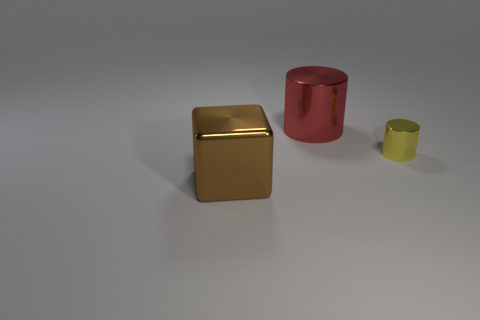Add 1 red metal cylinders. How many objects exist? 4 Subtract all cylinders. How many objects are left? 1 Add 2 cyan cylinders. How many cyan cylinders exist? 2 Subtract 0 purple cylinders. How many objects are left? 3 Subtract all cyan metallic spheres. Subtract all brown cubes. How many objects are left? 2 Add 3 small objects. How many small objects are left? 4 